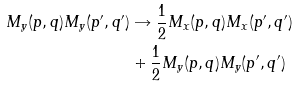Convert formula to latex. <formula><loc_0><loc_0><loc_500><loc_500>M _ { y } ( p , q ) M _ { y } ( p ^ { \prime } , q ^ { \prime } ) & \rightarrow \frac { 1 } { 2 } M _ { x } ( p , q ) M _ { x } ( p ^ { \prime } , q ^ { \prime } ) \\ & + \frac { 1 } { 2 } M _ { y } ( p , q ) M _ { y } ( p ^ { \prime } , q ^ { \prime } )</formula> 